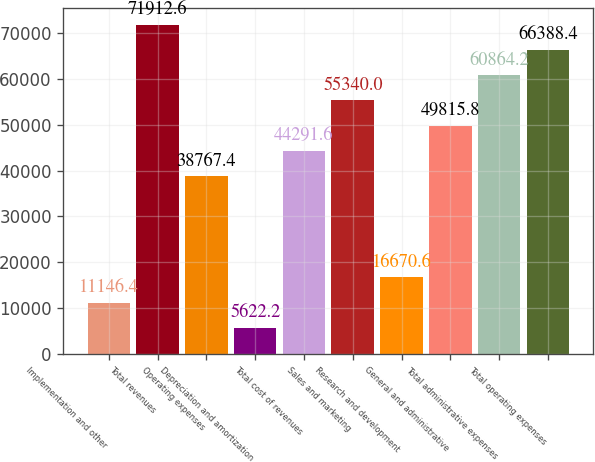<chart> <loc_0><loc_0><loc_500><loc_500><bar_chart><fcel>Implementation and other<fcel>Total revenues<fcel>Operating expenses<fcel>Depreciation and amortization<fcel>Total cost of revenues<fcel>Sales and marketing<fcel>Research and development<fcel>General and administrative<fcel>Total administrative expenses<fcel>Total operating expenses<nl><fcel>11146.4<fcel>71912.6<fcel>38767.4<fcel>5622.2<fcel>44291.6<fcel>55340<fcel>16670.6<fcel>49815.8<fcel>60864.2<fcel>66388.4<nl></chart> 